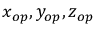<formula> <loc_0><loc_0><loc_500><loc_500>x _ { o p } , y _ { o p } , z _ { o p }</formula> 